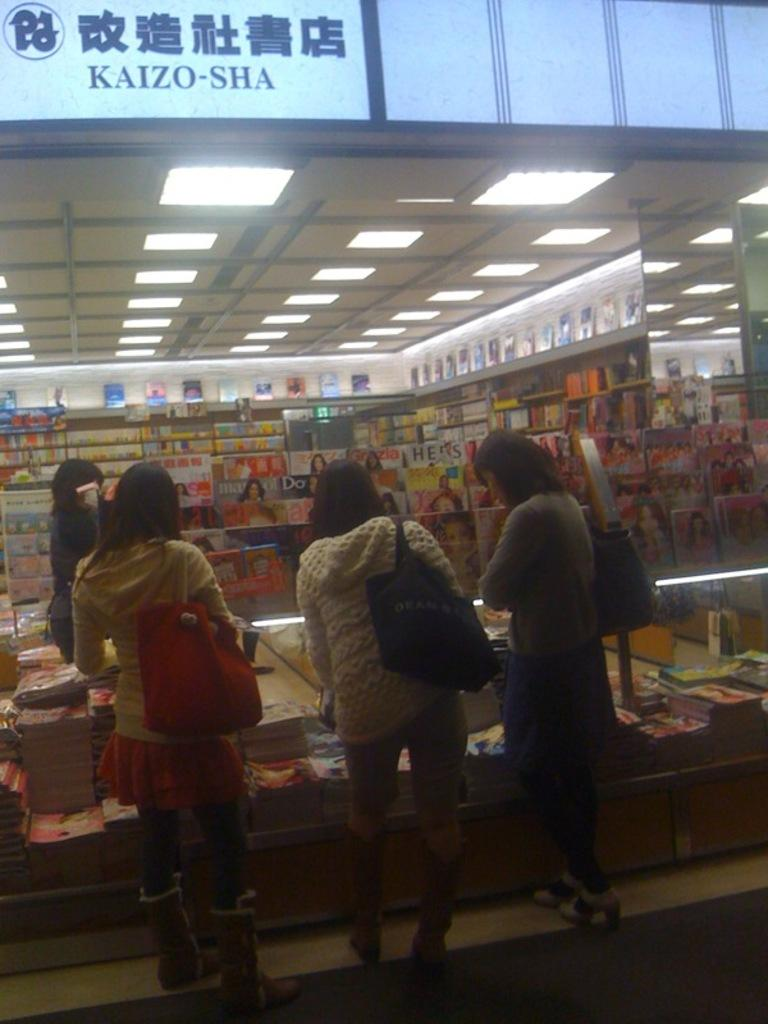<image>
Share a concise interpretation of the image provided. Some women browse magazines and books at the Kaizo-Sha store. 